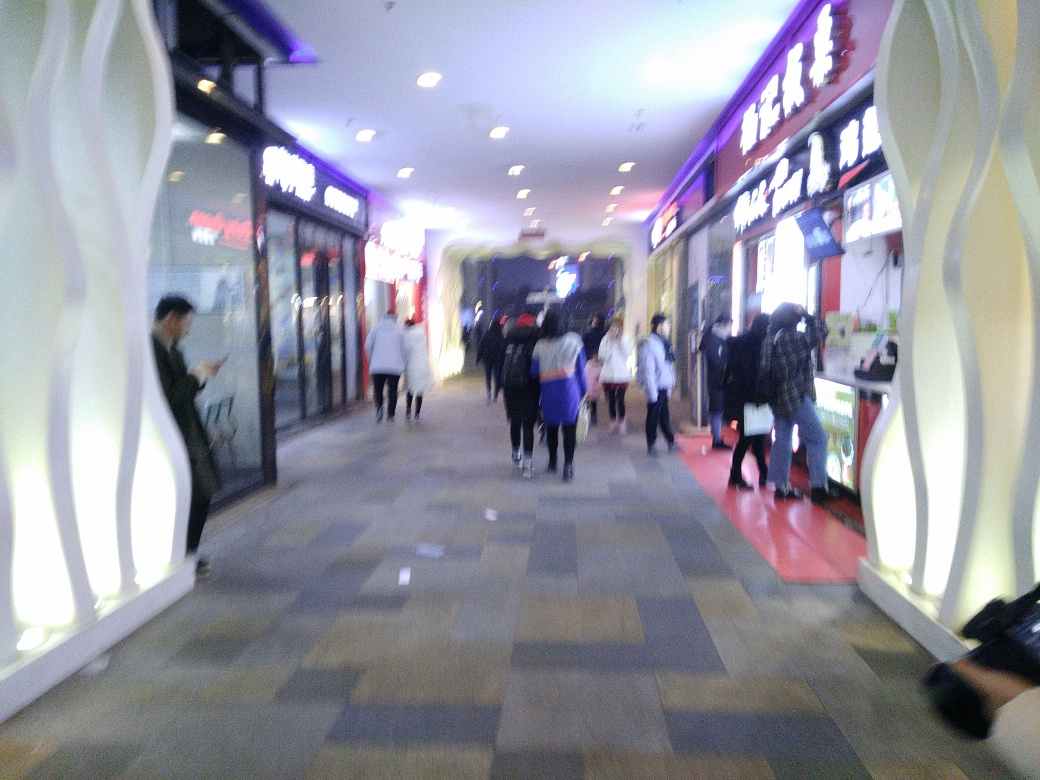Can you tell what type of location is depicted in the image? Based on the context, it appears to be an indoor setting, possibly a shopping mall or retail space, indicated by storefront signage and the presence of people who seem to be shopping or walking through. 